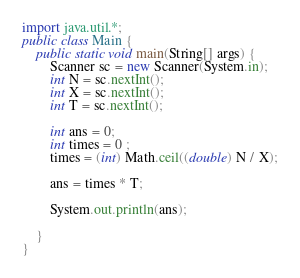<code> <loc_0><loc_0><loc_500><loc_500><_Java_>import java.util.*;
public class Main {
    public static void main(String[] args) {
        Scanner sc = new Scanner(System.in);
        int N = sc.nextInt();
        int X = sc.nextInt();
        int T = sc.nextInt();

        int ans = 0;
        int times = 0 ;
        times = (int) Math.ceil((double) N / X);

        ans = times * T;

        System.out.println(ans);

    }
}</code> 